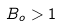Convert formula to latex. <formula><loc_0><loc_0><loc_500><loc_500>B _ { o } > 1</formula> 